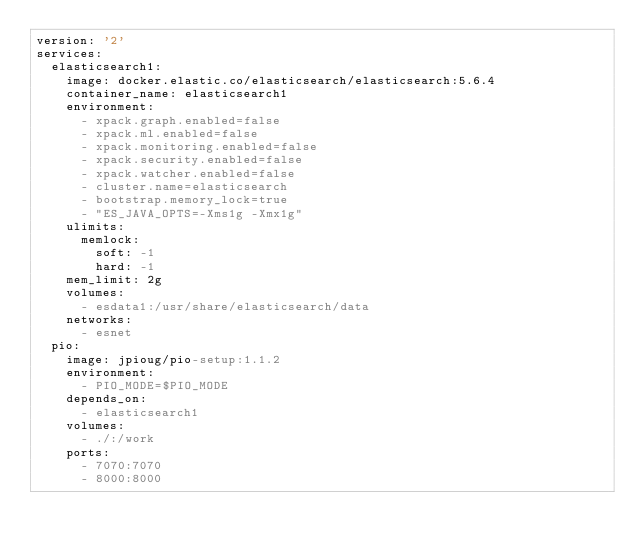<code> <loc_0><loc_0><loc_500><loc_500><_YAML_>version: '2'
services:
  elasticsearch1:
    image: docker.elastic.co/elasticsearch/elasticsearch:5.6.4
    container_name: elasticsearch1
    environment:
      - xpack.graph.enabled=false
      - xpack.ml.enabled=false
      - xpack.monitoring.enabled=false
      - xpack.security.enabled=false
      - xpack.watcher.enabled=false
      - cluster.name=elasticsearch
      - bootstrap.memory_lock=true
      - "ES_JAVA_OPTS=-Xms1g -Xmx1g"
    ulimits:
      memlock:
        soft: -1
        hard: -1
    mem_limit: 2g
    volumes:
      - esdata1:/usr/share/elasticsearch/data
    networks:
      - esnet
  pio:
    image: jpioug/pio-setup:1.1.2
    environment:
      - PIO_MODE=$PIO_MODE
    depends_on:
      - elasticsearch1
    volumes:
      - ./:/work
    ports:
      - 7070:7070
      - 8000:8000</code> 